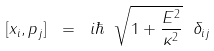Convert formula to latex. <formula><loc_0><loc_0><loc_500><loc_500>[ x _ { i } , p _ { j } ] \ = \ i \hbar { \ } \sqrt { 1 + \frac { E ^ { 2 } } { \kappa ^ { 2 } } } \ \delta _ { i j }</formula> 